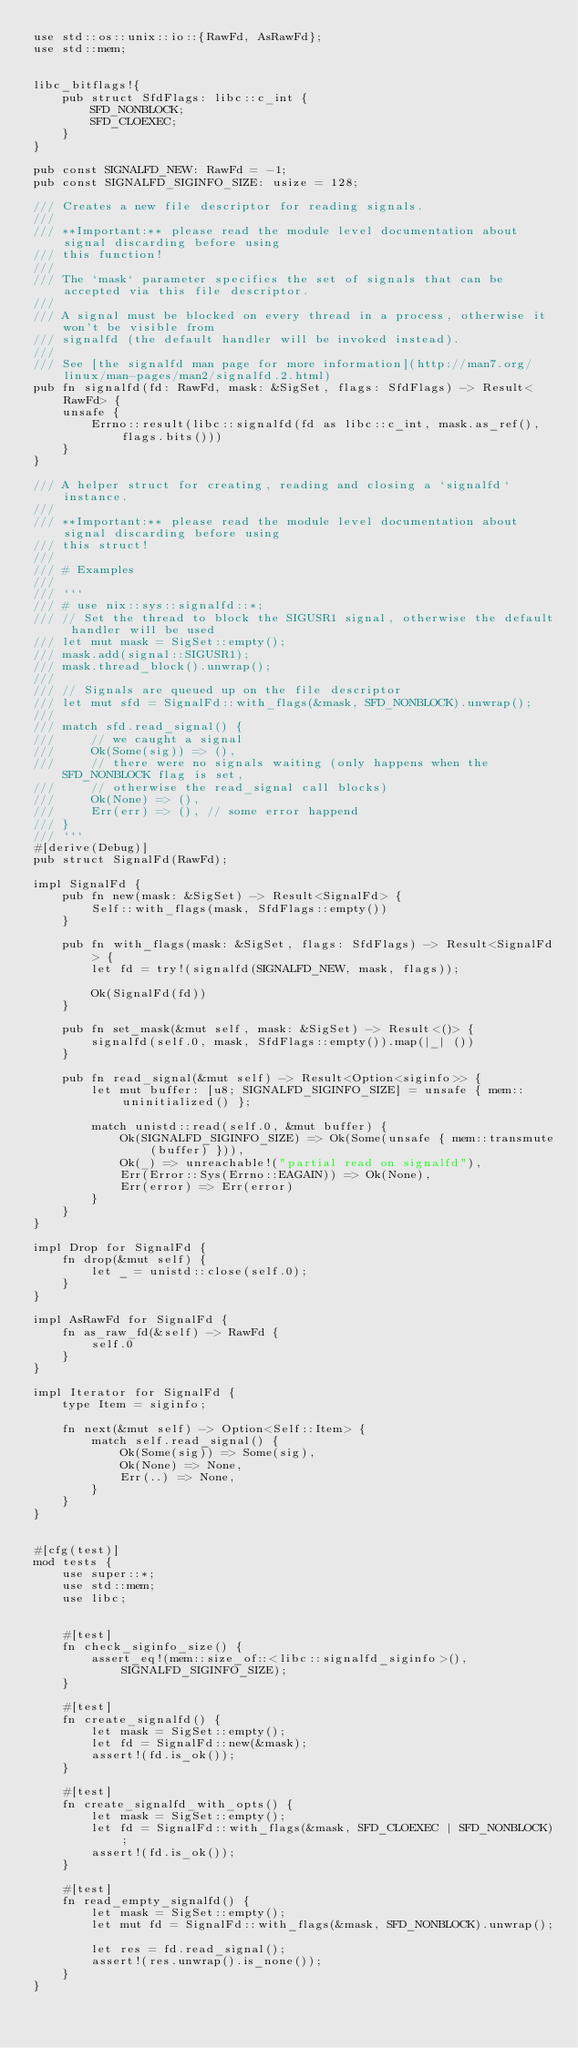<code> <loc_0><loc_0><loc_500><loc_500><_Rust_>use std::os::unix::io::{RawFd, AsRawFd};
use std::mem;


libc_bitflags!{
    pub struct SfdFlags: libc::c_int {
        SFD_NONBLOCK;
        SFD_CLOEXEC;
    }
}

pub const SIGNALFD_NEW: RawFd = -1;
pub const SIGNALFD_SIGINFO_SIZE: usize = 128;

/// Creates a new file descriptor for reading signals.
///
/// **Important:** please read the module level documentation about signal discarding before using
/// this function!
///
/// The `mask` parameter specifies the set of signals that can be accepted via this file descriptor.
///
/// A signal must be blocked on every thread in a process, otherwise it won't be visible from
/// signalfd (the default handler will be invoked instead).
///
/// See [the signalfd man page for more information](http://man7.org/linux/man-pages/man2/signalfd.2.html)
pub fn signalfd(fd: RawFd, mask: &SigSet, flags: SfdFlags) -> Result<RawFd> {
    unsafe {
        Errno::result(libc::signalfd(fd as libc::c_int, mask.as_ref(), flags.bits()))
    }
}

/// A helper struct for creating, reading and closing a `signalfd` instance.
///
/// **Important:** please read the module level documentation about signal discarding before using
/// this struct!
///
/// # Examples
///
/// ```
/// # use nix::sys::signalfd::*;
/// // Set the thread to block the SIGUSR1 signal, otherwise the default handler will be used
/// let mut mask = SigSet::empty();
/// mask.add(signal::SIGUSR1);
/// mask.thread_block().unwrap();
///
/// // Signals are queued up on the file descriptor
/// let mut sfd = SignalFd::with_flags(&mask, SFD_NONBLOCK).unwrap();
///
/// match sfd.read_signal() {
///     // we caught a signal
///     Ok(Some(sig)) => (),
///     // there were no signals waiting (only happens when the SFD_NONBLOCK flag is set,
///     // otherwise the read_signal call blocks)
///     Ok(None) => (),
///     Err(err) => (), // some error happend
/// }
/// ```
#[derive(Debug)]
pub struct SignalFd(RawFd);

impl SignalFd {
    pub fn new(mask: &SigSet) -> Result<SignalFd> {
        Self::with_flags(mask, SfdFlags::empty())
    }

    pub fn with_flags(mask: &SigSet, flags: SfdFlags) -> Result<SignalFd> {
        let fd = try!(signalfd(SIGNALFD_NEW, mask, flags));

        Ok(SignalFd(fd))
    }

    pub fn set_mask(&mut self, mask: &SigSet) -> Result<()> {
        signalfd(self.0, mask, SfdFlags::empty()).map(|_| ())
    }

    pub fn read_signal(&mut self) -> Result<Option<siginfo>> {
        let mut buffer: [u8; SIGNALFD_SIGINFO_SIZE] = unsafe { mem::uninitialized() };

        match unistd::read(self.0, &mut buffer) {
            Ok(SIGNALFD_SIGINFO_SIZE) => Ok(Some(unsafe { mem::transmute(buffer) })),
            Ok(_) => unreachable!("partial read on signalfd"),
            Err(Error::Sys(Errno::EAGAIN)) => Ok(None),
            Err(error) => Err(error)
        }
    }
}

impl Drop for SignalFd {
    fn drop(&mut self) {
        let _ = unistd::close(self.0);
    }
}

impl AsRawFd for SignalFd {
    fn as_raw_fd(&self) -> RawFd {
        self.0
    }
}

impl Iterator for SignalFd {
    type Item = siginfo;

    fn next(&mut self) -> Option<Self::Item> {
        match self.read_signal() {
            Ok(Some(sig)) => Some(sig),
            Ok(None) => None,
            Err(..) => None,
        }
    }
}


#[cfg(test)]
mod tests {
    use super::*;
    use std::mem;
    use libc;


    #[test]
    fn check_siginfo_size() {
        assert_eq!(mem::size_of::<libc::signalfd_siginfo>(), SIGNALFD_SIGINFO_SIZE);
    }

    #[test]
    fn create_signalfd() {
        let mask = SigSet::empty();
        let fd = SignalFd::new(&mask);
        assert!(fd.is_ok());
    }

    #[test]
    fn create_signalfd_with_opts() {
        let mask = SigSet::empty();
        let fd = SignalFd::with_flags(&mask, SFD_CLOEXEC | SFD_NONBLOCK);
        assert!(fd.is_ok());
    }

    #[test]
    fn read_empty_signalfd() {
        let mask = SigSet::empty();
        let mut fd = SignalFd::with_flags(&mask, SFD_NONBLOCK).unwrap();

        let res = fd.read_signal();
        assert!(res.unwrap().is_none());
    }
}
</code> 